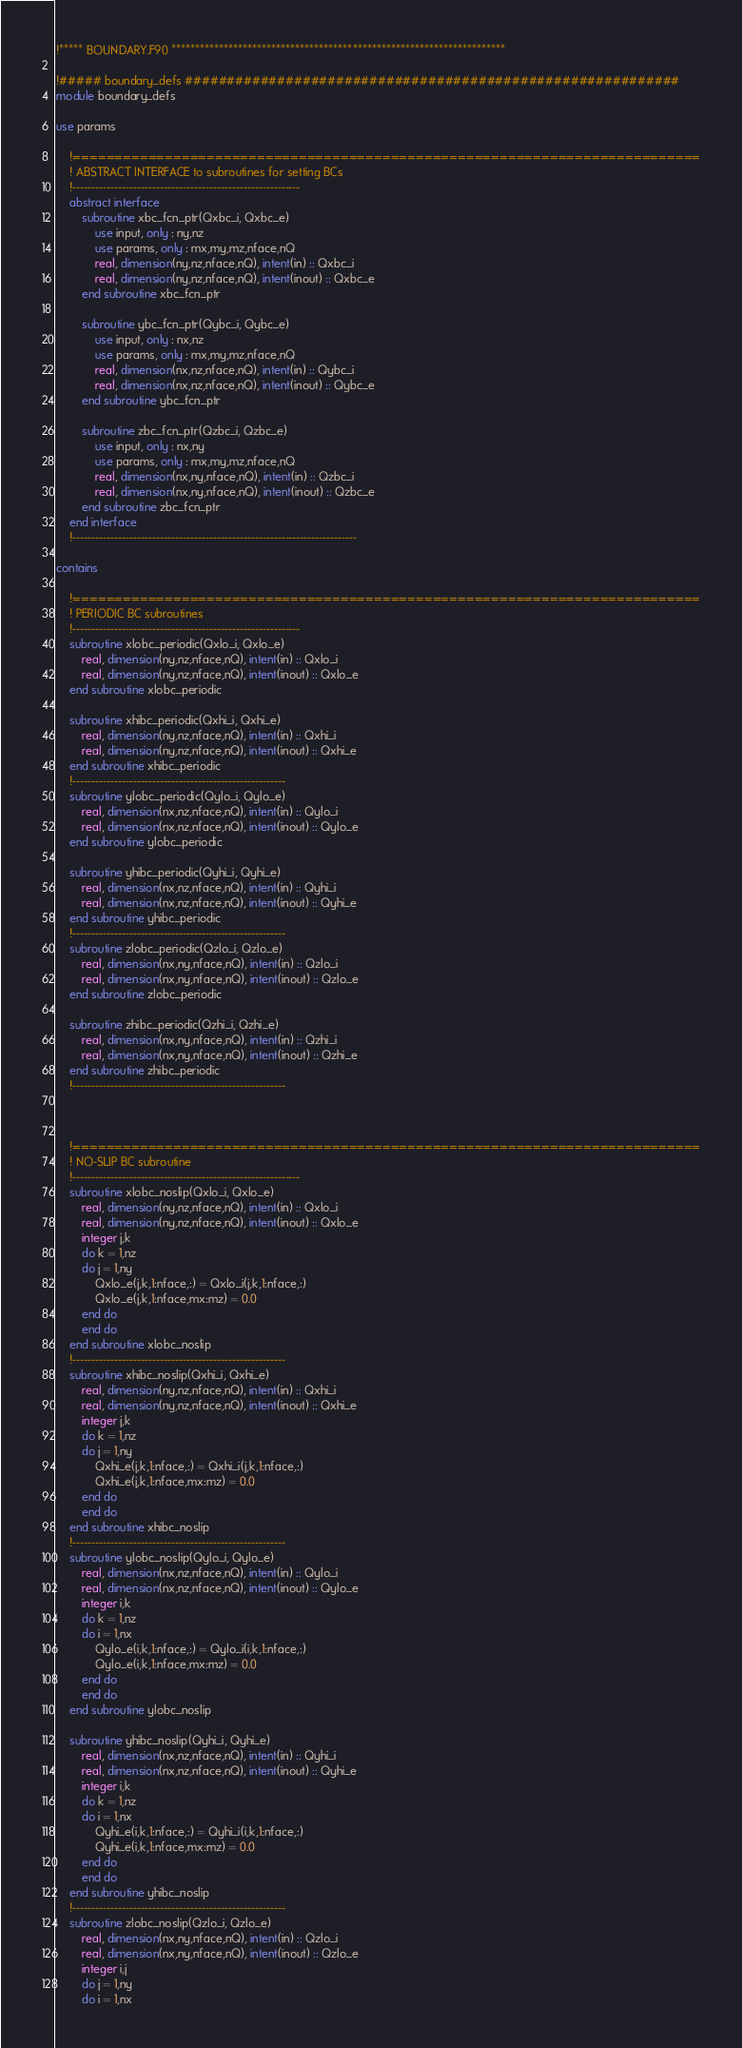<code> <loc_0><loc_0><loc_500><loc_500><_FORTRAN_>!***** BOUNDARY.F90 **********************************************************************

!##### boundary_defs ###########################################################
module boundary_defs

use params

    !===========================================================================
    ! ABSTRACT INTERFACE to subroutines for setting BCs
    !------------------------------------------------------------
    abstract interface
        subroutine xbc_fcn_ptr(Qxbc_i, Qxbc_e)
            use input, only : ny,nz
            use params, only : mx,my,mz,nface,nQ
            real, dimension(ny,nz,nface,nQ), intent(in) :: Qxbc_i
            real, dimension(ny,nz,nface,nQ), intent(inout) :: Qxbc_e
        end subroutine xbc_fcn_ptr

        subroutine ybc_fcn_ptr(Qybc_i, Qybc_e)
            use input, only : nx,nz
            use params, only : mx,my,mz,nface,nQ
            real, dimension(nx,nz,nface,nQ), intent(in) :: Qybc_i
            real, dimension(nx,nz,nface,nQ), intent(inout) :: Qybc_e
        end subroutine ybc_fcn_ptr

        subroutine zbc_fcn_ptr(Qzbc_i, Qzbc_e)
            use input, only : nx,ny
            use params, only : mx,my,mz,nface,nQ
            real, dimension(nx,ny,nface,nQ), intent(in) :: Qzbc_i
            real, dimension(nx,ny,nface,nQ), intent(inout) :: Qzbc_e
        end subroutine zbc_fcn_ptr
    end interface
    !---------------------------------------------------------------------------

contains

    !===========================================================================
    ! PERIODIC BC subroutines
    !------------------------------------------------------------
    subroutine xlobc_periodic(Qxlo_i, Qxlo_e)
        real, dimension(ny,nz,nface,nQ), intent(in) :: Qxlo_i
        real, dimension(ny,nz,nface,nQ), intent(inout) :: Qxlo_e
    end subroutine xlobc_periodic

    subroutine xhibc_periodic(Qxhi_i, Qxhi_e)
        real, dimension(ny,nz,nface,nQ), intent(in) :: Qxhi_i
        real, dimension(ny,nz,nface,nQ), intent(inout) :: Qxhi_e
    end subroutine xhibc_periodic
    !--------------------------------------------------------
    subroutine ylobc_periodic(Qylo_i, Qylo_e)
        real, dimension(nx,nz,nface,nQ), intent(in) :: Qylo_i
        real, dimension(nx,nz,nface,nQ), intent(inout) :: Qylo_e
    end subroutine ylobc_periodic

    subroutine yhibc_periodic(Qyhi_i, Qyhi_e)
        real, dimension(nx,nz,nface,nQ), intent(in) :: Qyhi_i
        real, dimension(nx,nz,nface,nQ), intent(inout) :: Qyhi_e
    end subroutine yhibc_periodic
    !--------------------------------------------------------
    subroutine zlobc_periodic(Qzlo_i, Qzlo_e)
        real, dimension(nx,ny,nface,nQ), intent(in) :: Qzlo_i
        real, dimension(nx,ny,nface,nQ), intent(inout) :: Qzlo_e
    end subroutine zlobc_periodic

    subroutine zhibc_periodic(Qzhi_i, Qzhi_e)
        real, dimension(nx,ny,nface,nQ), intent(in) :: Qzhi_i
        real, dimension(nx,ny,nface,nQ), intent(inout) :: Qzhi_e
    end subroutine zhibc_periodic
    !--------------------------------------------------------



    !===========================================================================
    ! NO-SLIP BC subroutine
    !------------------------------------------------------------
    subroutine xlobc_noslip(Qxlo_i, Qxlo_e)
        real, dimension(ny,nz,nface,nQ), intent(in) :: Qxlo_i
        real, dimension(ny,nz,nface,nQ), intent(inout) :: Qxlo_e
        integer j,k
        do k = 1,nz
        do j = 1,ny
            Qxlo_e(j,k,1:nface,:) = Qxlo_i(j,k,1:nface,:)
            Qxlo_e(j,k,1:nface,mx:mz) = 0.0
        end do
        end do
    end subroutine xlobc_noslip
    !--------------------------------------------------------
    subroutine xhibc_noslip(Qxhi_i, Qxhi_e)
        real, dimension(ny,nz,nface,nQ), intent(in) :: Qxhi_i
        real, dimension(ny,nz,nface,nQ), intent(inout) :: Qxhi_e
        integer j,k
        do k = 1,nz
        do j = 1,ny
            Qxhi_e(j,k,1:nface,:) = Qxhi_i(j,k,1:nface,:)
            Qxhi_e(j,k,1:nface,mx:mz) = 0.0
        end do
        end do
    end subroutine xhibc_noslip
    !--------------------------------------------------------
    subroutine ylobc_noslip(Qylo_i, Qylo_e)
        real, dimension(nx,nz,nface,nQ), intent(in) :: Qylo_i
        real, dimension(nx,nz,nface,nQ), intent(inout) :: Qylo_e
        integer i,k
        do k = 1,nz
        do i = 1,nx
            Qylo_e(i,k,1:nface,:) = Qylo_i(i,k,1:nface,:)
            Qylo_e(i,k,1:nface,mx:mz) = 0.0
        end do
        end do
    end subroutine ylobc_noslip

    subroutine yhibc_noslip(Qyhi_i, Qyhi_e)
        real, dimension(nx,nz,nface,nQ), intent(in) :: Qyhi_i
        real, dimension(nx,nz,nface,nQ), intent(inout) :: Qyhi_e
        integer i,k
        do k = 1,nz
        do i = 1,nx
            Qyhi_e(i,k,1:nface,:) = Qyhi_i(i,k,1:nface,:)
            Qyhi_e(i,k,1:nface,mx:mz) = 0.0
        end do
        end do
    end subroutine yhibc_noslip
    !--------------------------------------------------------
    subroutine zlobc_noslip(Qzlo_i, Qzlo_e)
        real, dimension(nx,ny,nface,nQ), intent(in) :: Qzlo_i
        real, dimension(nx,ny,nface,nQ), intent(inout) :: Qzlo_e
        integer i,j
        do j = 1,ny
        do i = 1,nx</code> 